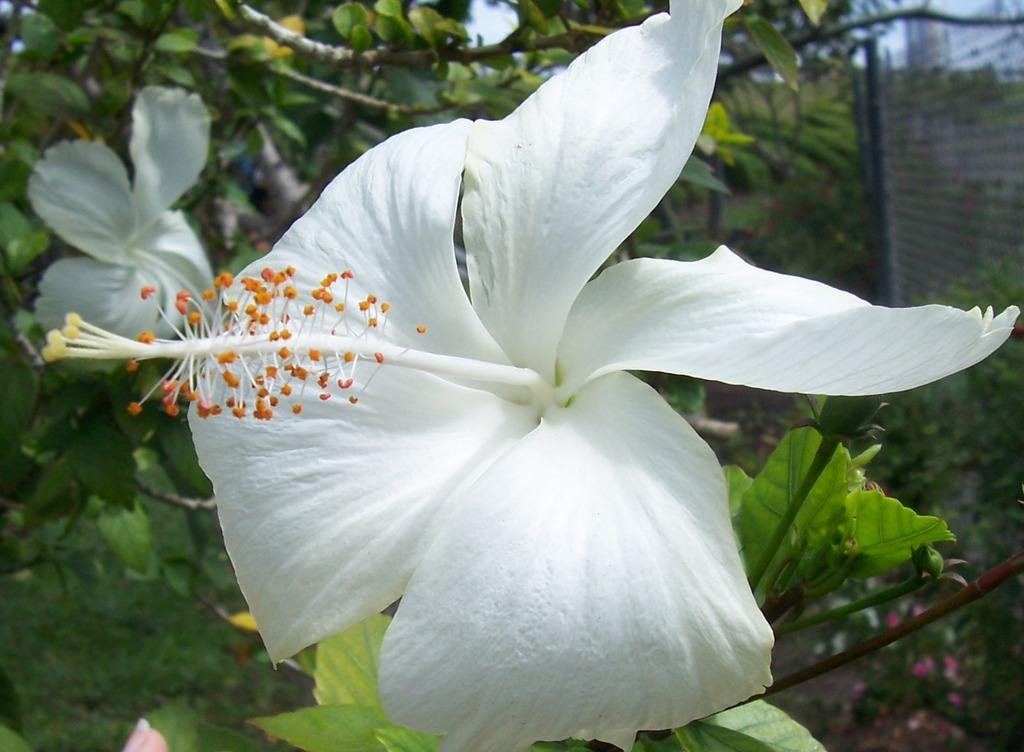What type of living organisms can be seen in the image? There are flowers and plants visible in the image. What can be seen in the background of the image? There are trees in the background of the image. What is located on the right side of the image? There is a metal fence on the right side of the image. How many goldfish can be seen swimming in the image? There are no goldfish present in the image. What type of scene is depicted in the image? The image does not depict a specific scene; it simply shows flowers, plants, trees, and a metal fence. 